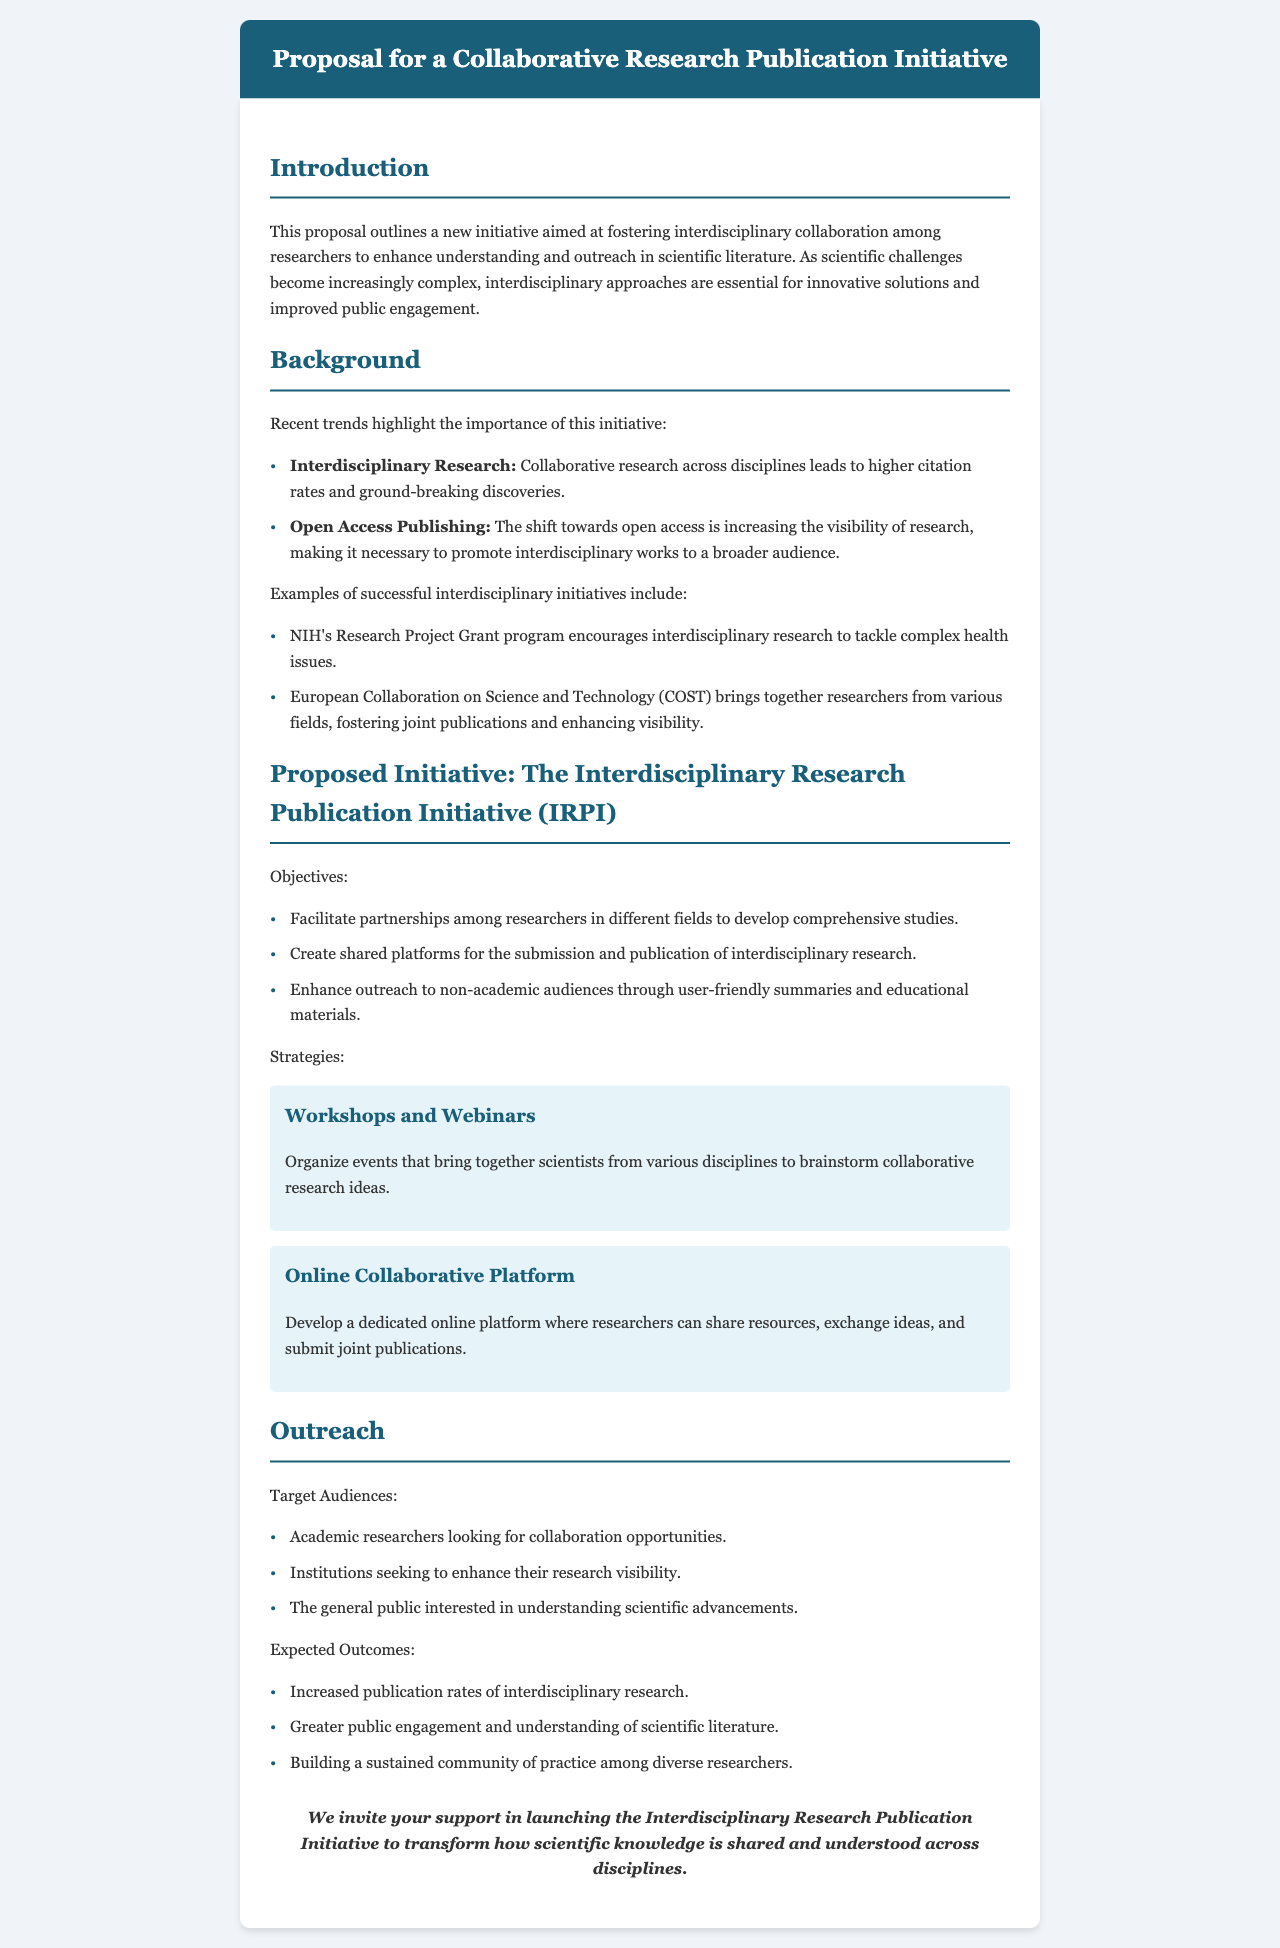What is the title of the proposal? The title of the proposal is mentioned clearly at the top of the document.
Answer: Proposal for a Collaborative Research Publication Initiative What does IRPI stand for? The abbreviation IRPI is explained within the context of the proposed initiative.
Answer: Interdisciplinary Research Publication Initiative What are the two recent trends highlighted in the background section? The trends mentioned are essential to understanding the rationale behind the initiative.
Answer: Interdisciplinary Research, Open Access Publishing What is one expected outcome of the initiative? The expected outcomes are detailed in the outreach section, indicating the goals of the proposal.
Answer: Increased publication rates of interdisciplinary research What type of events will be organized as part of the strategies? The document lists specific types of events aimed at fostering collaboration among researchers.
Answer: Workshops and Webinars What audience is targeted for outreach? This is specified in the outreach section, detailing whom the initiative aims to engage.
Answer: Academic researchers How will the initiative enhance outreach? The document provides a specific strategy pertaining to outreach efforts.
Answer: User-friendly summaries and educational materials What is one strategy mentioned for the initiative? The strategies section outlines various methods to achieve the initiative's goals.
Answer: Online Collaborative Platform How many objectives are listed for the proposed initiative? The number of objectives is specified in the initiatives section.
Answer: Three 